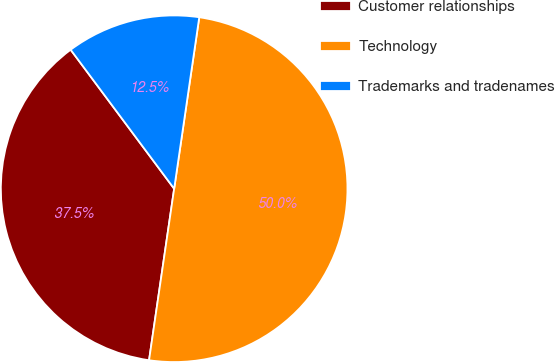Convert chart to OTSL. <chart><loc_0><loc_0><loc_500><loc_500><pie_chart><fcel>Customer relationships<fcel>Technology<fcel>Trademarks and tradenames<nl><fcel>37.5%<fcel>50.0%<fcel>12.5%<nl></chart> 